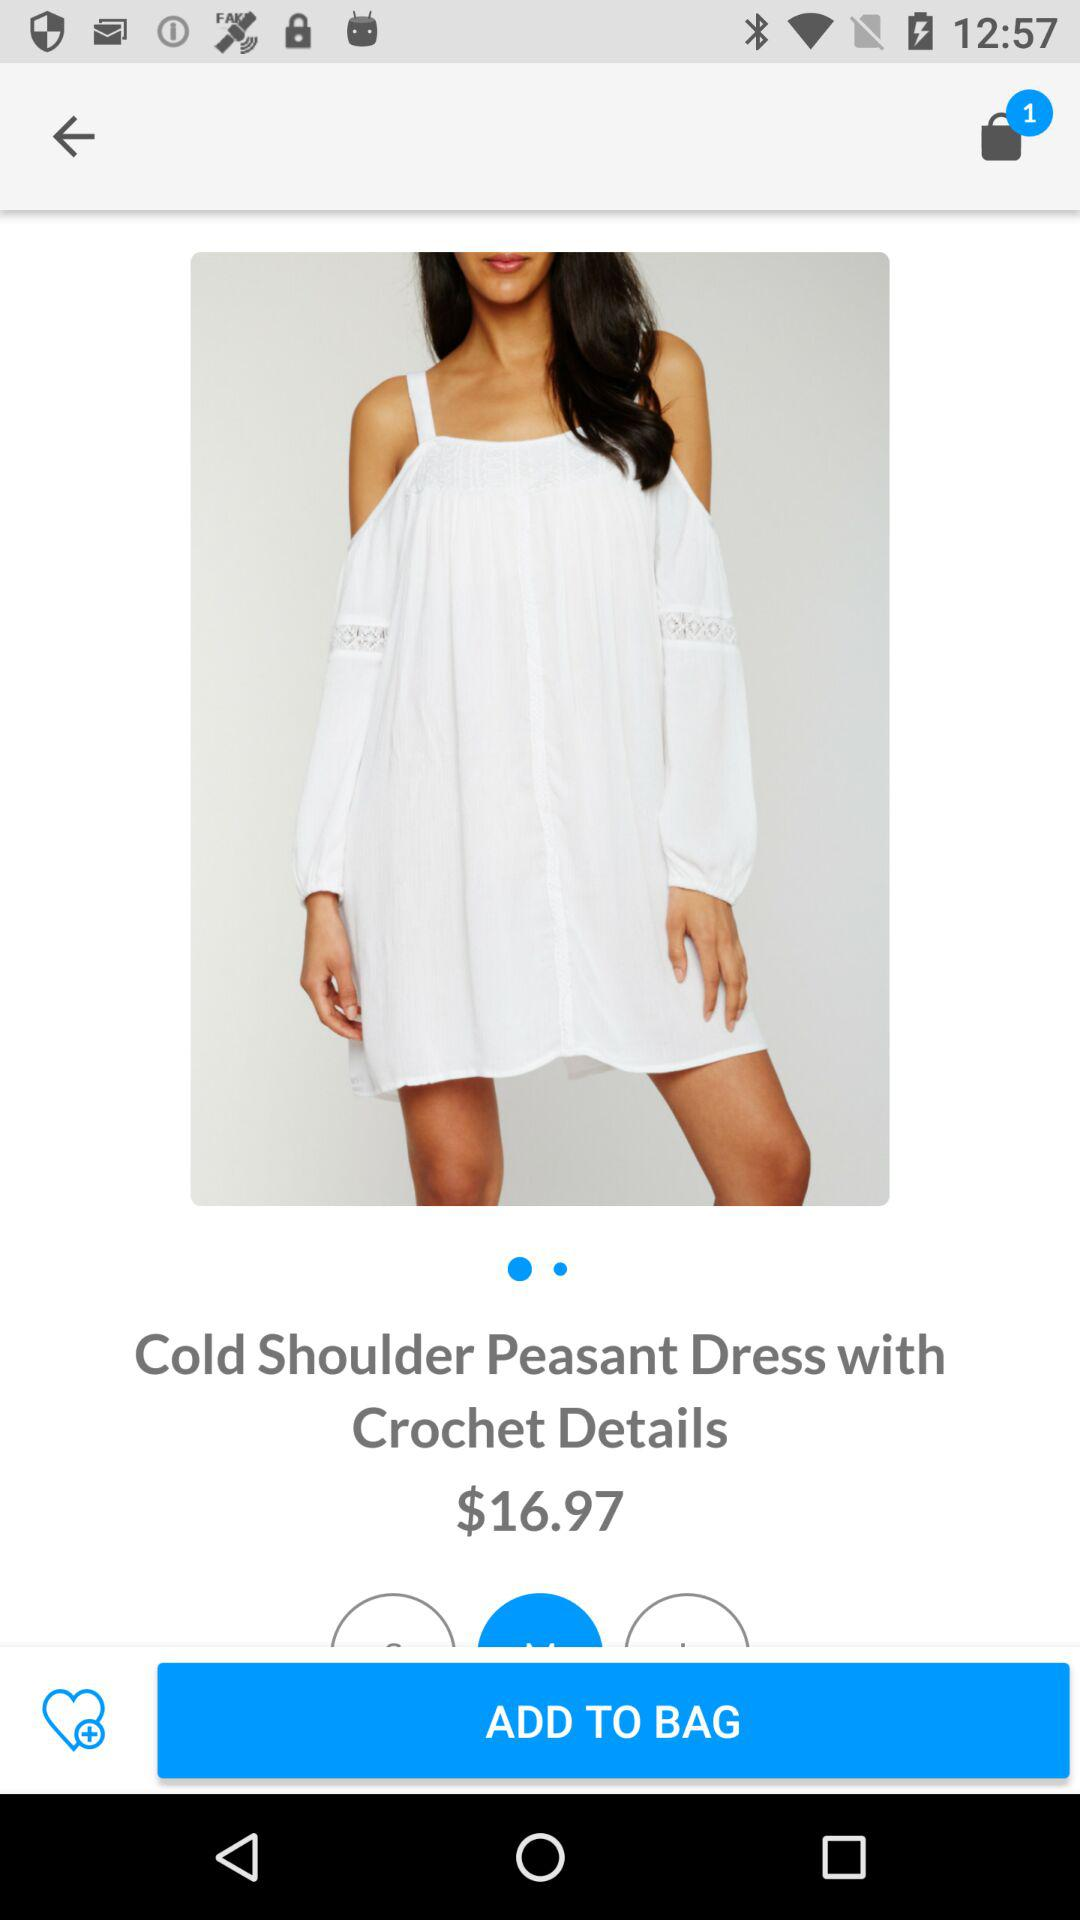What is the price of the Cold Shoulder Peasant Dress? The price is $16.97. 